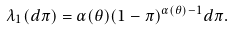Convert formula to latex. <formula><loc_0><loc_0><loc_500><loc_500>\lambda _ { 1 } ( d \pi ) = \alpha ( \theta ) ( 1 - \pi ) ^ { \alpha ( \theta ) - 1 } d \pi .</formula> 